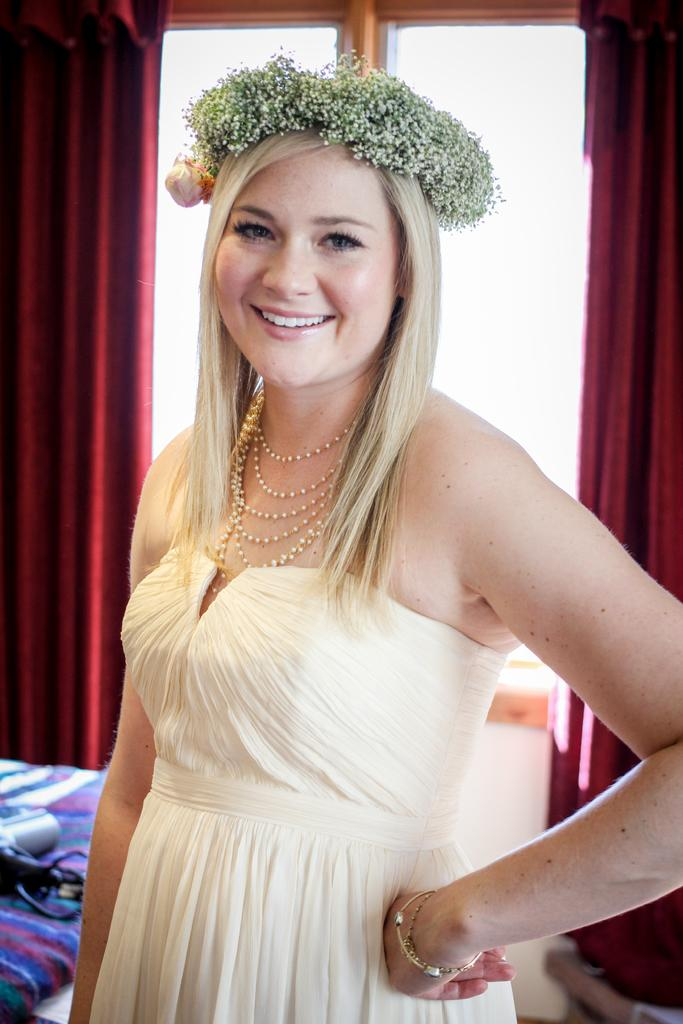Who is present in the image? There is a person in the image. What is the person wearing? The person is wearing a white dress. What can be seen in the background of the image? There is a window and curtains in maroon color in the background of the image. How many cattle can be seen in the image? There are no cattle present in the image. Are there any boys visible in the image? The provided facts do not mention any boys in the image. 